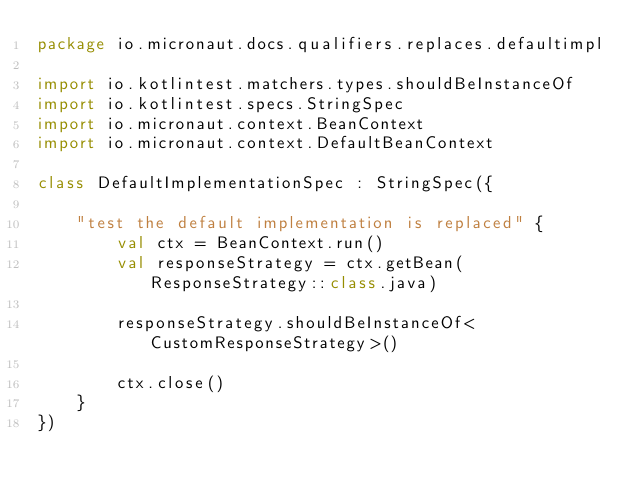Convert code to text. <code><loc_0><loc_0><loc_500><loc_500><_Kotlin_>package io.micronaut.docs.qualifiers.replaces.defaultimpl

import io.kotlintest.matchers.types.shouldBeInstanceOf
import io.kotlintest.specs.StringSpec
import io.micronaut.context.BeanContext
import io.micronaut.context.DefaultBeanContext

class DefaultImplementationSpec : StringSpec({

    "test the default implementation is replaced" {
        val ctx = BeanContext.run()
        val responseStrategy = ctx.getBean(ResponseStrategy::class.java)

        responseStrategy.shouldBeInstanceOf<CustomResponseStrategy>()

        ctx.close()
    }
})</code> 